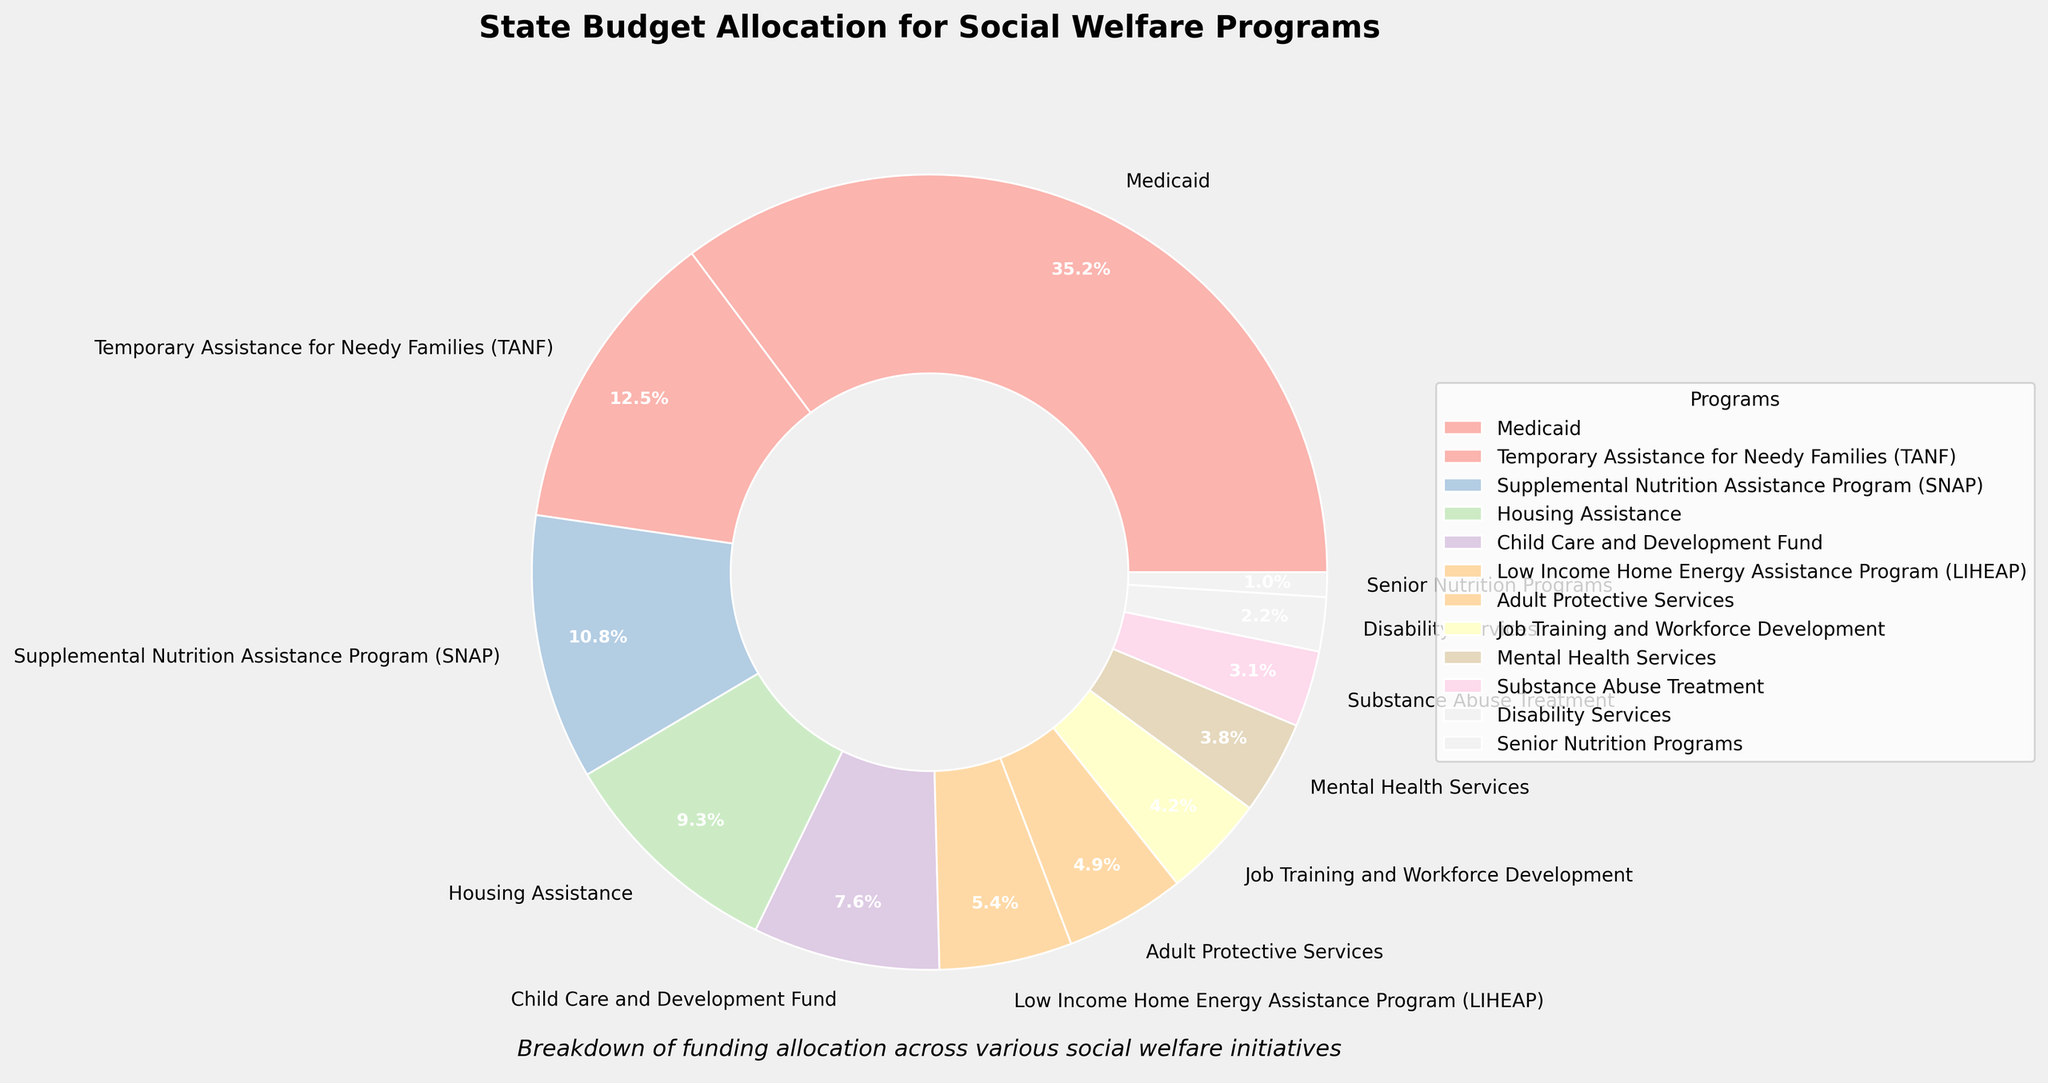What percentage of the state budget is allocated to Medicaid? The pie chart shows different programs and their budget allocations. To find this, locate the wedge labeled "Medicaid" and note the percentage displayed.
Answer: 35.2% What is the difference between the budget allocations for Temporary Assistance for Needy Families (TANF) and Supplemental Nutrition Assistance Program (SNAP)? First, identify the percentages for TANF and SNAP from the pie chart. TANF is 12.5% and SNAP is 10.8%. Subtract SNAP's percentage from TANF's percentage: 12.5% - 10.8% = 1.7%.
Answer: 1.7% Which program receives a higher budget allocation, Housing Assistance or Child Care and Development Fund? Find the percentage allocations for Housing Assistance and Child Care and Development Fund on the pie chart. Housing Assistance is 9.3%, and Child Care and Development Fund is 7.6%. Compare them to see which is higher.
Answer: Housing Assistance What is the combined budget allocation for Mental Health Services and Substance Abuse Treatment? Identify the percentages for both programs in the pie chart. Mental Health Services is 3.8%, and Substance Abuse Treatment is 3.1%. Add these values to get the combined allocation: 3.8% + 3.1% = 6.9%.
Answer: 6.9% How many programs have a budget allocation greater than 5%? Count the wedges in the pie chart that have a percentage label greater than 5%. They are Medicaid (35.2%), TANF (12.5%), SNAP (10.8%), Housing Assistance (9.3%), and Child Care and Development Fund (7.6%).
Answer: 5 Which program has the smallest budget allocation? Locate the wedge with the smallest percentage on the pie chart. The smallest percentage shown is for Senior Nutrition Programs with 1.0%.
Answer: Senior Nutrition Programs How does the budget allocation for Job Training and Workforce Development compare to that for Adult Protective Services? Compare the values from the pie chart: Job Training and Workforce Development is 4.2%, and Adult Protective Services is 4.9%. Therefore, Adult Protective Services has a higher allocation.
Answer: Adult Protective Services has a higher allocation What is the sum of the budget allocations for the top three funded programs? Identify the top three funded programs from the pie chart: Medicaid (35.2%), TANF (12.5%), and SNAP (10.8%). Add these values to get the total: 35.2% + 12.5% + 10.8% = 58.5%.
Answer: 58.5% Compare the budget allocation for LIHEAP to the average budget allocation of Adult Protective Services and Disability Services. Find the percentages: LIHEAP is 5.4%, Adult Protective Services is 4.9%, and Disability Services is 2.2%. Calculate the average of Adult Protective Services and Disability Services: (4.9% + 2.2%) / 2 = 3.55%. Compare 5.4% and 3.55%.
Answer: LIHEAP has a higher allocation How many programs receive less than 3% of the budget allocation? Count the wedges in the pie chart that have a percentage label less than 3%. They are Disability Services (2.2%) and Senior Nutrition Programs (1.0%).
Answer: 2 